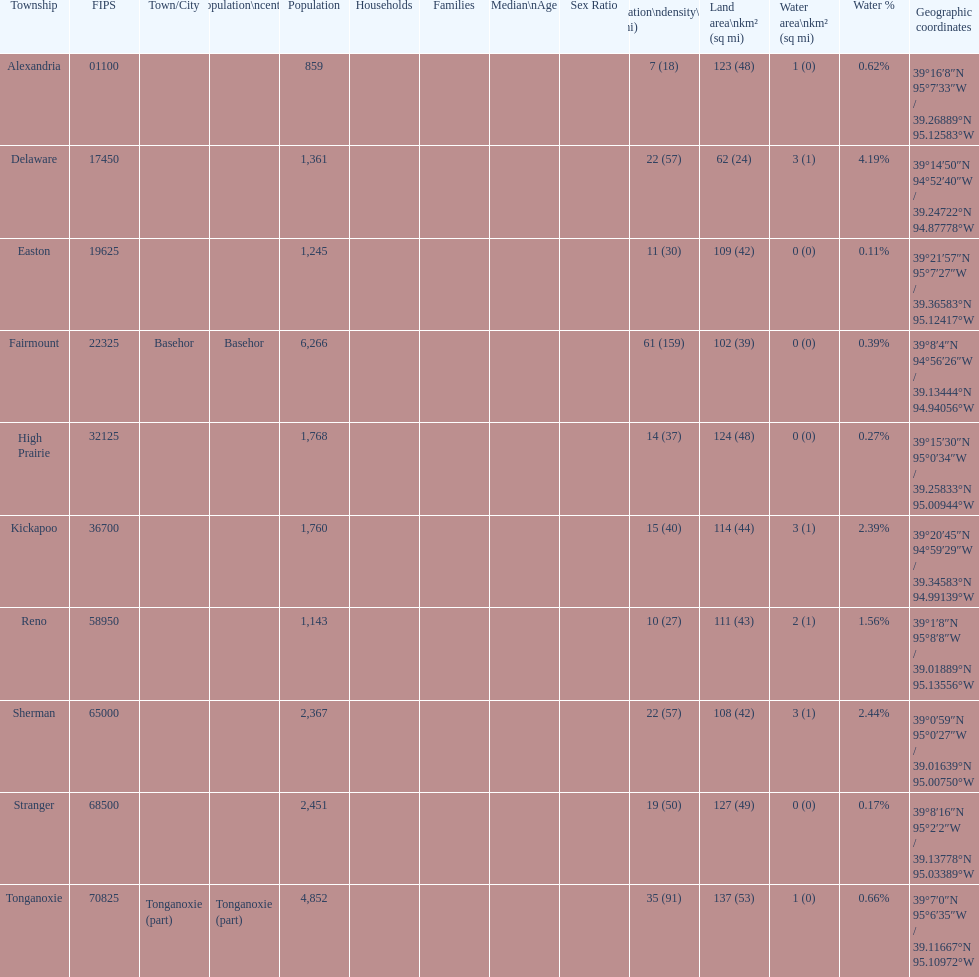What is the difference of population in easton and reno? 102. 